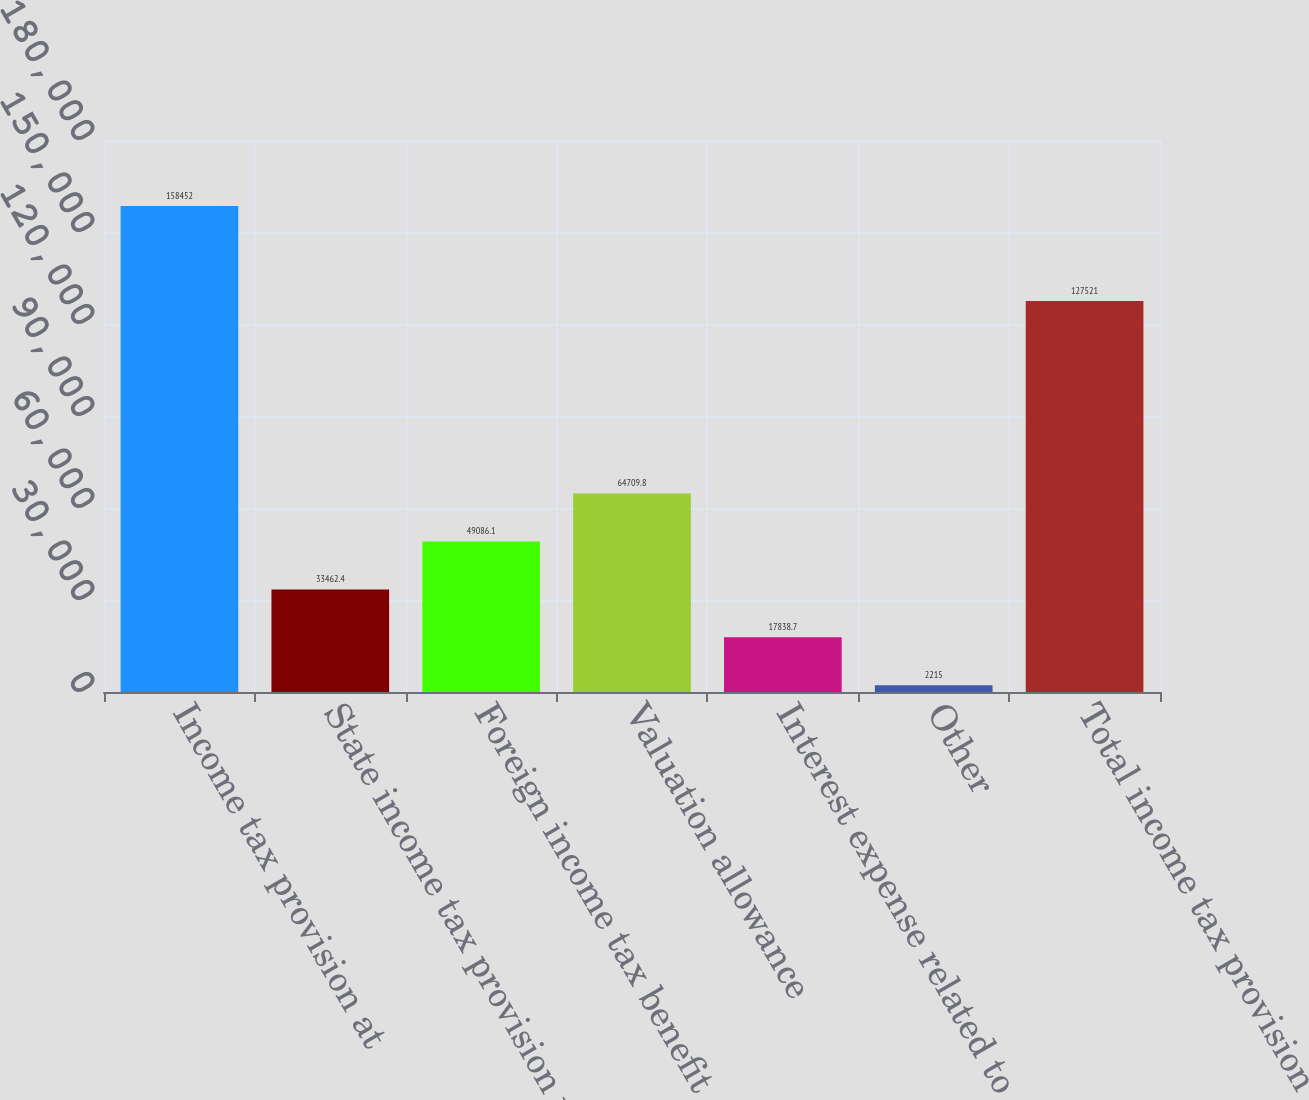Convert chart. <chart><loc_0><loc_0><loc_500><loc_500><bar_chart><fcel>Income tax provision at<fcel>State income tax provision net<fcel>Foreign income tax benefit<fcel>Valuation allowance<fcel>Interest expense related to<fcel>Other<fcel>Total income tax provision<nl><fcel>158452<fcel>33462.4<fcel>49086.1<fcel>64709.8<fcel>17838.7<fcel>2215<fcel>127521<nl></chart> 